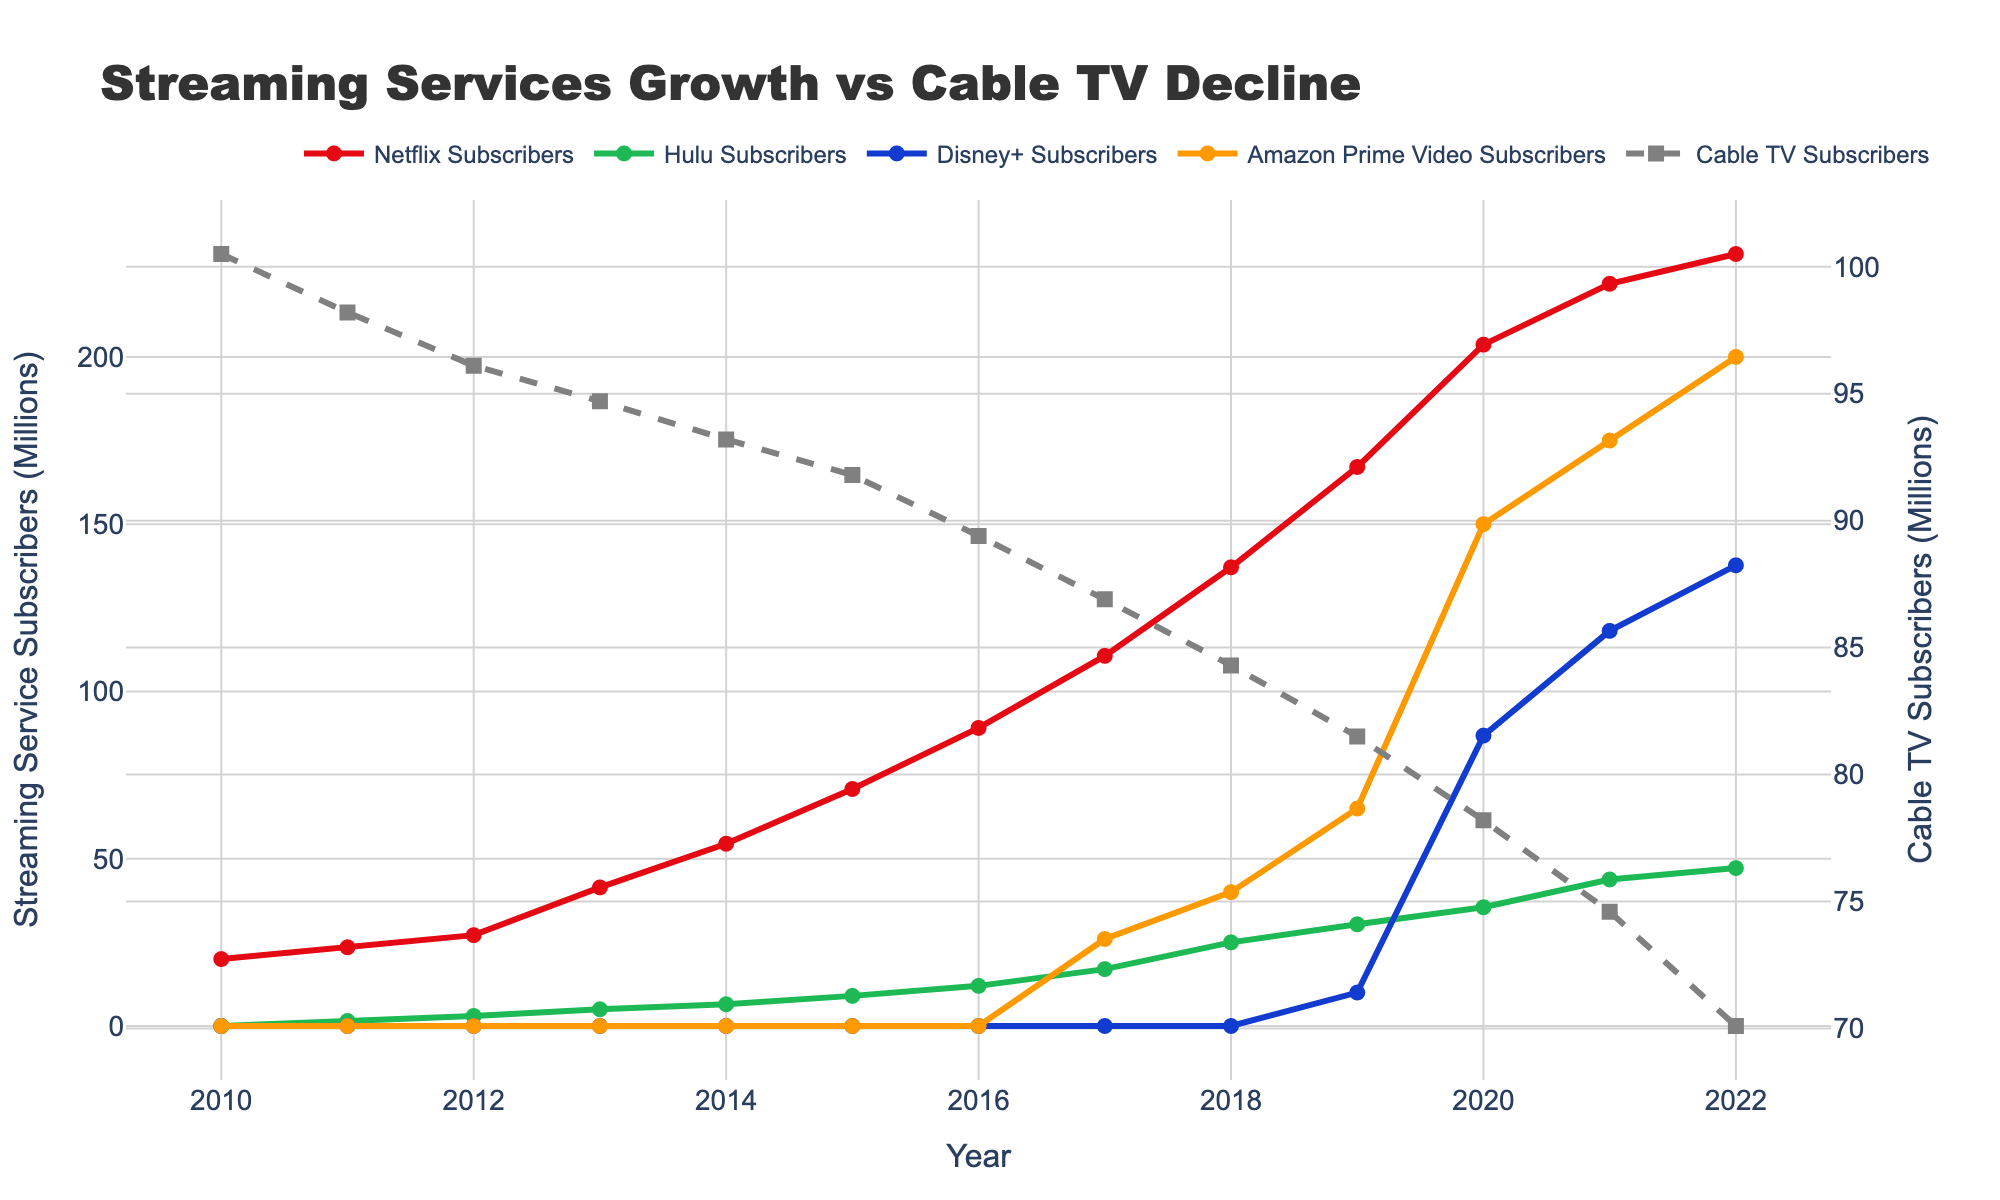what's the difference in the number of subscribers between Netflix and Hulu in 2020? In 2020, Netflix Subscribers and Hulu Subscribers are respectively about 203.66 million and 35.5 million. The difference is 203.66 - 35.5
Answer: 168.16 how many more subscribers did Amazon Prime Video have compared to Disney+ in 2021? In 2021, Amazon Prime Video Subscribers were 175 million, while Disney+ Subscribers were 118.1 million. The difference is 175 - 118.1
Answer: 56.9 which service saw the most significant growth between 2019 and 2020? By looking at the figure, Amazon Prime Video Subscribers show a dramatic increase from around 65 million in 2019 to 150 million in 2020. The increase is 150 - 65
Answer: Amazon Prime Video how many total subscribers did Netflix and Amazon Prime Video have combined in 2018? In 2018, Netflix Subscribers were 137.1 million and Amazon Prime Video Subscribers were 40 million. Total is 137.1 + 40
Answer: 177.1 what was the trend for Cable TV Subscribers from 2010 to 2022? The figure shows a consistent decline in Cable TV Subscribers from 100.5 million in 2010 to 70.1 million in 2022
Answer: Declining which streaming service had the least subscribers in 2017? According to the figure, all services other than Amazon Prime Video had existing numbers, Hulu had the least with about 17 million
Answer: Hulu what was the average number of Hulu Subscribers from 2010 to 2022? Sum all the Hulu Subscribers from 2010 to 2022, which is (0+1.5+3+5+6.5+9+12+17+25+30.4+35.5+43.8+47.2)=235.9, then divide by the number of years (13)
Answer: 18.15 compare the total growth in subscribers between Netflix and Cable TV from 2010 to 2022 Netflix grew from 20.01 million in 2010 to 230.75 in 2022 (230.75 - 20.01 = 210.74). Cable TV declined from 100.5 in 2010 to 70.1 in 2022 (100.5 - 70.1 = 30.4)
Answer: Netflix: 210.74, Cable TV: -30.4 